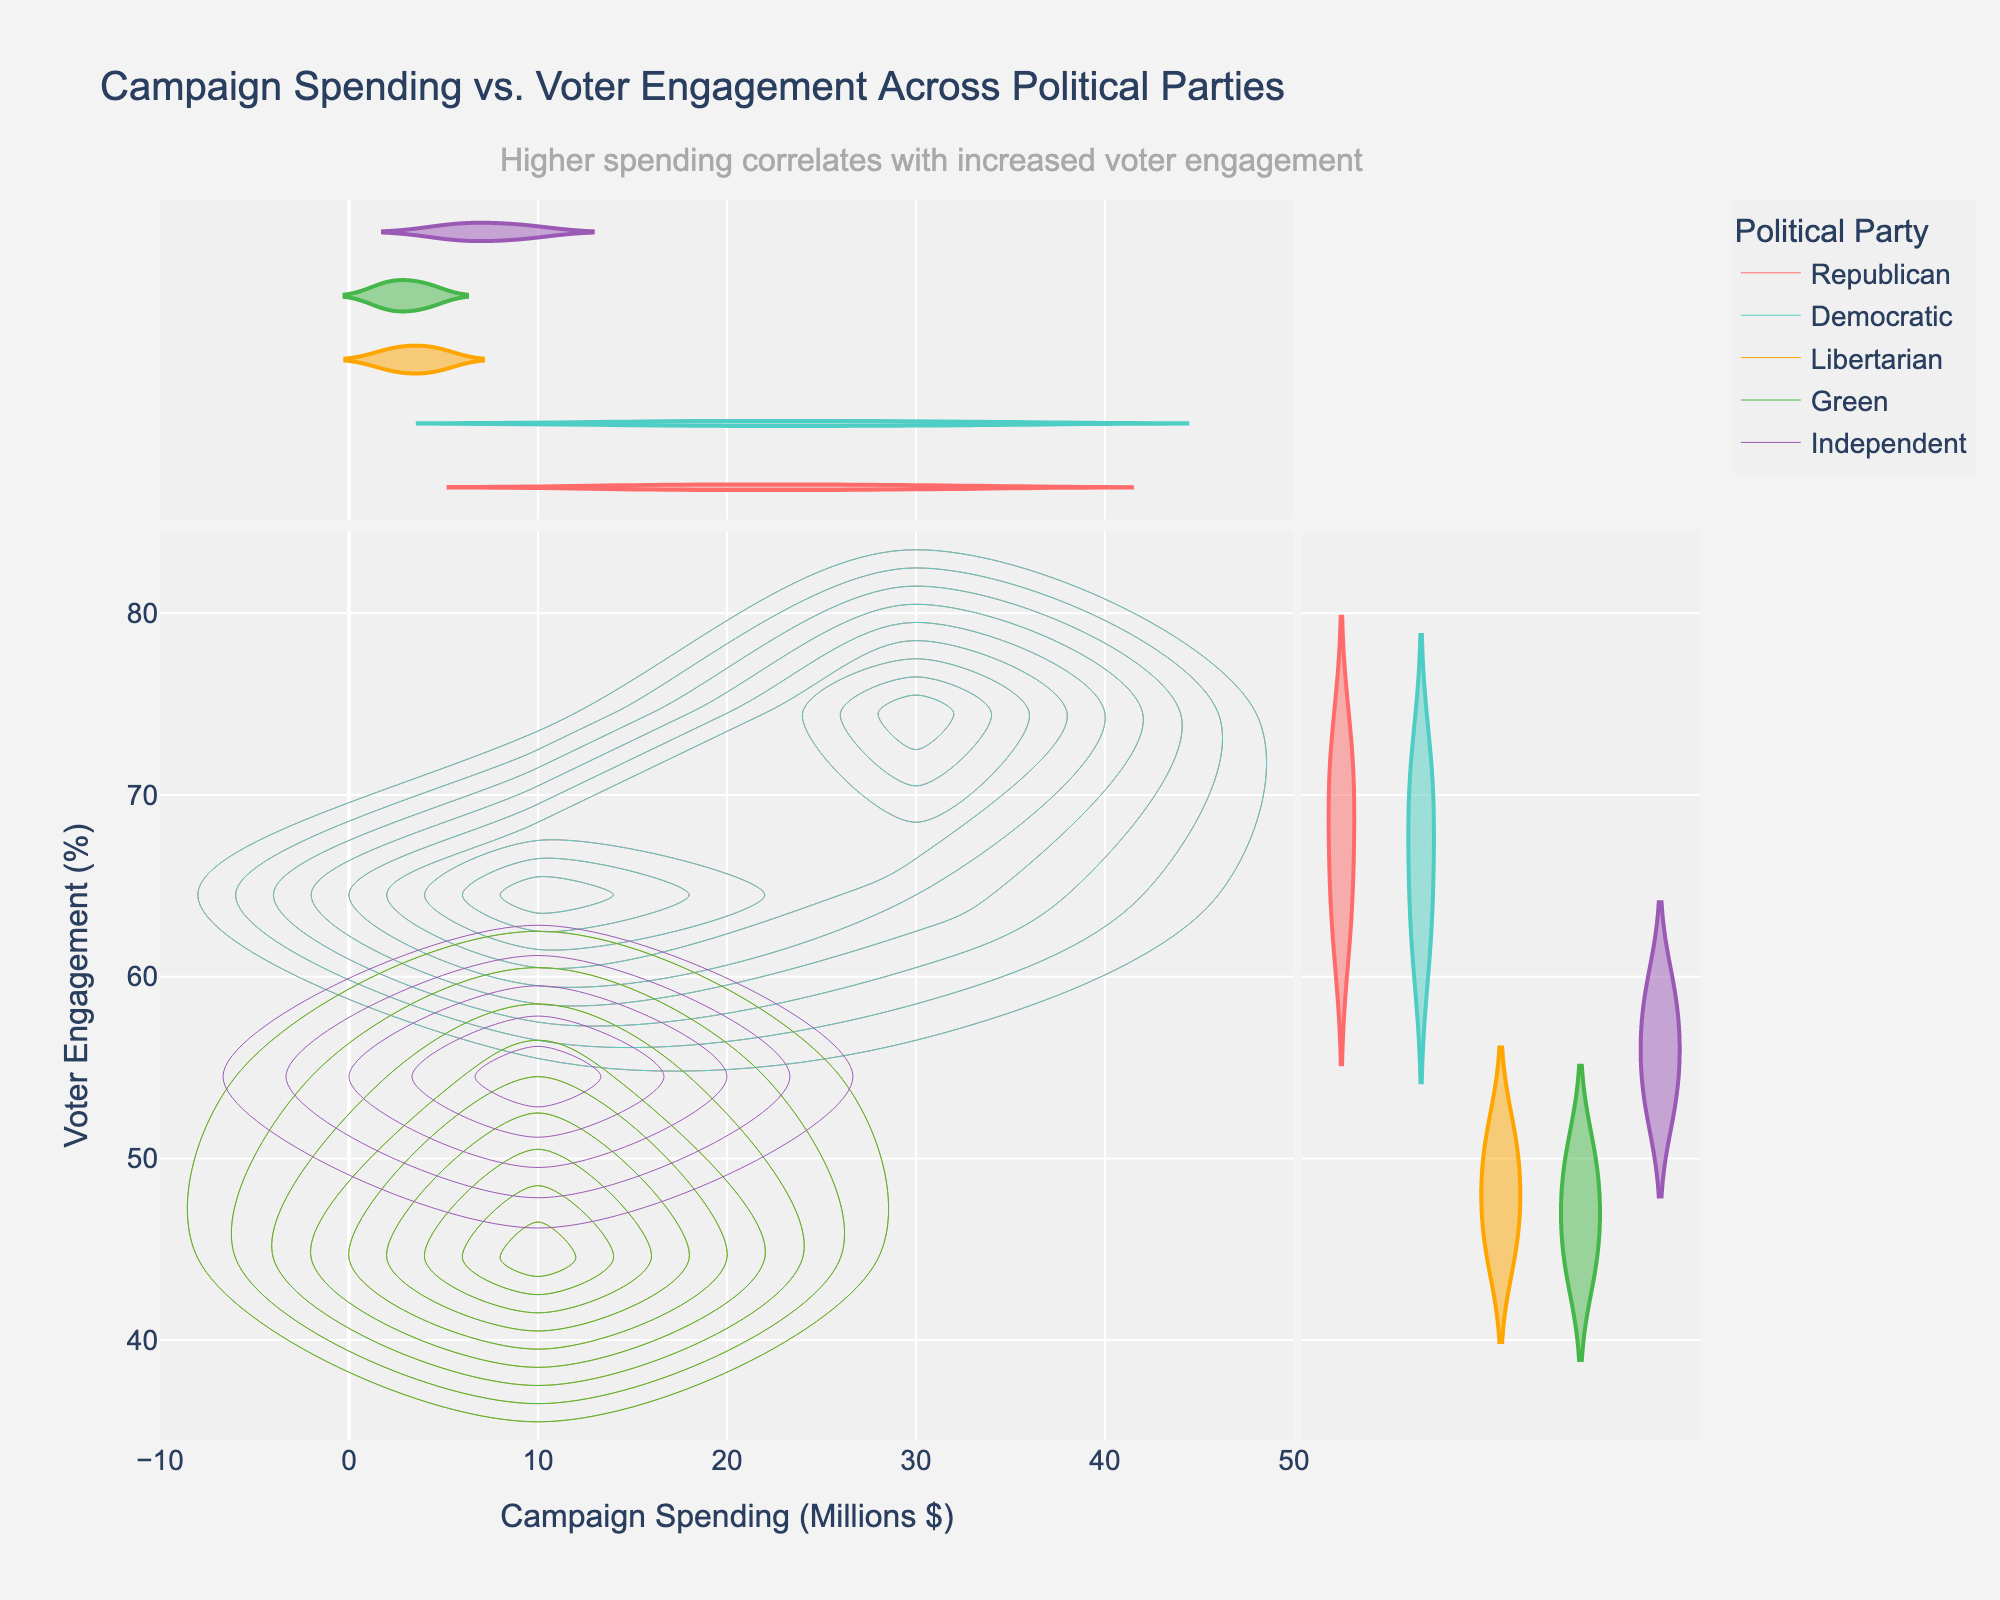What is the title of the plot? The title of the plot is displayed at the top and provides a summary of what the plot is about.
Answer: Campaign Spending vs. Voter Engagement Across Political Parties Which parties are represented by the colors in the plot? The colors in the plot legend indicate which colors are associated with which parties.
Answer: Republican, Democratic, Libertarian, Green, Independent What is the voter engagement percentage for the Democratic party at approximately $28.6 million in spending? Locate the Democratic color (cyan) on the plot and find the point where 'spending_millions' is around 28.6. Then, check the corresponding 'voter_engagement_percent' value.
Answer: 70% Between the Republican and Democratic parties, which one shows a higher maximum campaign spending? Compare the highest 'spending_millions' values for both Republican and Democratic parties by looking at the plot.
Answer: Republican Which party shows the lowest voter engagement percentage? Check the lowest 'voter_engagement_percent' value on the plot and identify the corresponding party color.
Answer: Green What does the density contour indicate in this plot? The density contour indicates areas with a higher concentration of data points. Darker or more filled contours represent higher densities.
Answer: Areas with a higher density of campaign spending and voter engagement Comparing the Republican and Independent parties, which one has a higher average voter engagement? Calculate the average 'voter_engagement_percent' for Republican and Independent parties separately and compare them.
Answer: Republican Which political party has the most variation in campaign spending? Look at the range of 'spending_millions' for each party and identify the one with the widest range.
Answer: Republican What can be inferred about the relationship between campaign spending and voter engagement from the plot? Assess the trend shown in the plot by observing how 'voter_engagement_percent' changes with 'spending_millions' for the different parties.
Answer: Higher spending correlates with increased voter engagement 